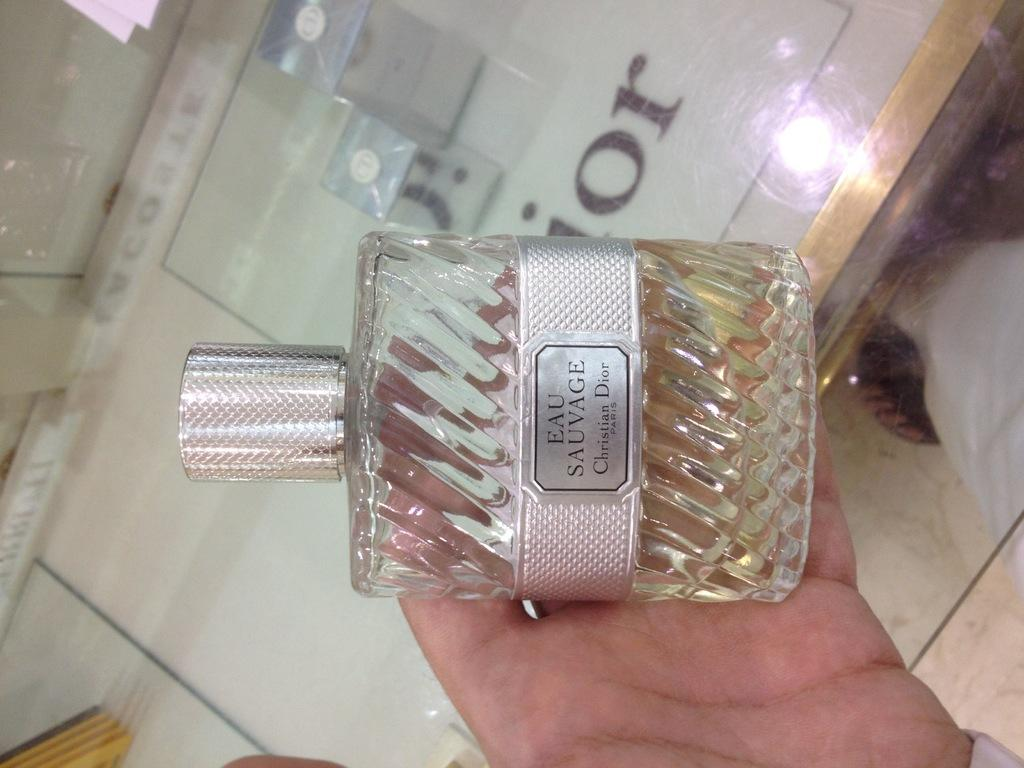<image>
Provide a brief description of the given image. A bottle of perfume named Eau Sauvage being held in a person's hand. 